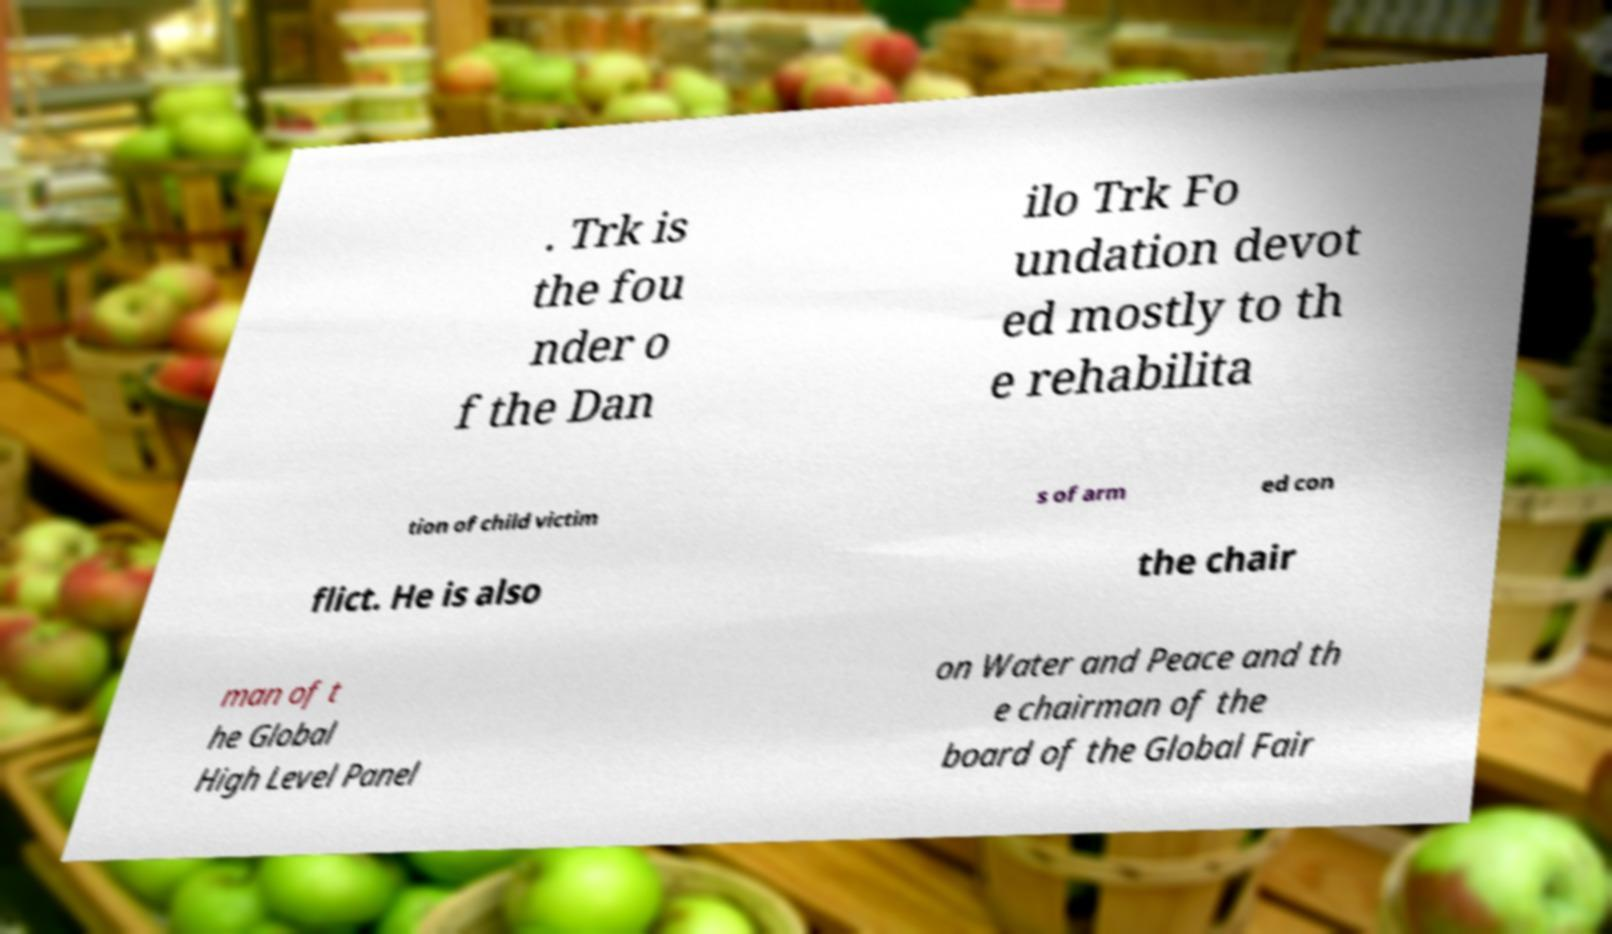Could you assist in decoding the text presented in this image and type it out clearly? . Trk is the fou nder o f the Dan ilo Trk Fo undation devot ed mostly to th e rehabilita tion of child victim s of arm ed con flict. He is also the chair man of t he Global High Level Panel on Water and Peace and th e chairman of the board of the Global Fair 